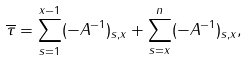Convert formula to latex. <formula><loc_0><loc_0><loc_500><loc_500>\overline { \tau } = \sum _ { s = 1 } ^ { x - 1 } ( - A ^ { - 1 } ) _ { s , x } + \sum _ { s = x } ^ { n } ( - A ^ { - 1 } ) _ { s , x } ,</formula> 